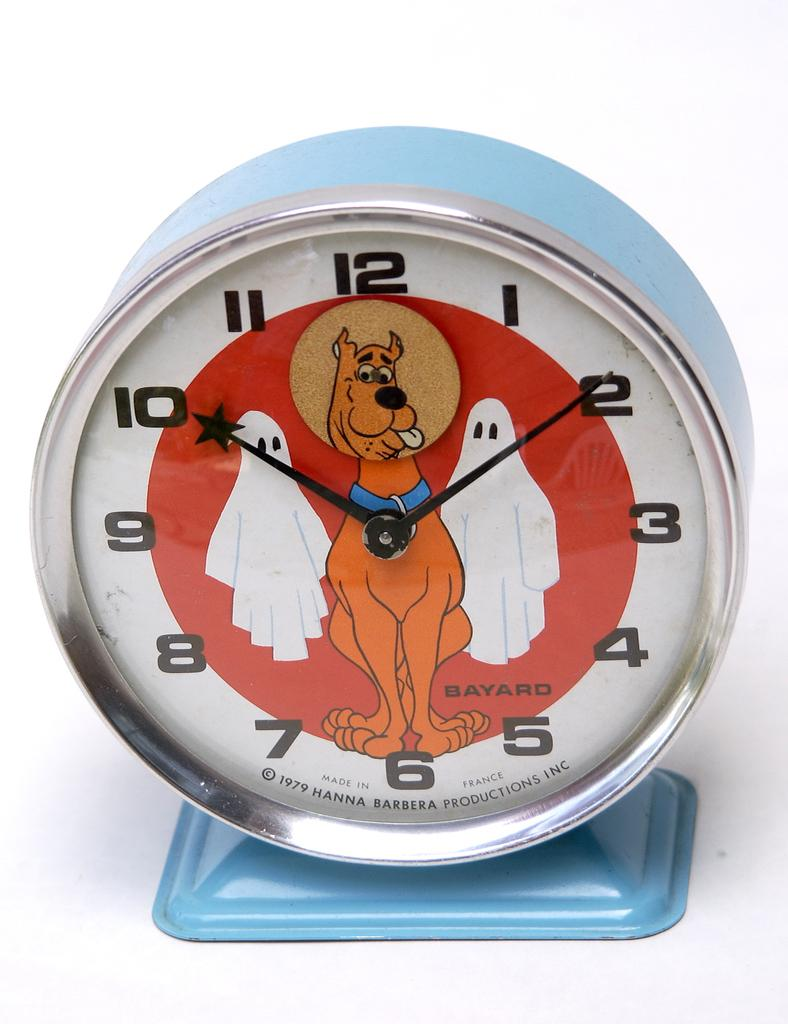<image>
Relay a brief, clear account of the picture shown. A Hanna Barbera Scooby doo watch made in France 